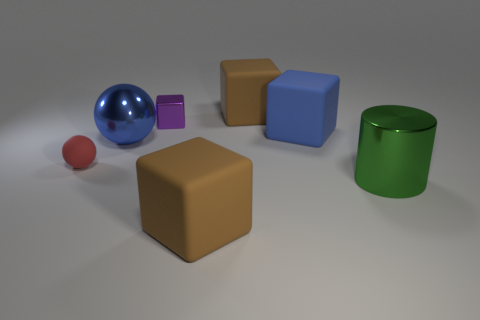The metallic block that is the same size as the red sphere is what color?
Your response must be concise. Purple. How many cylinders are yellow rubber objects or blue rubber things?
Your answer should be very brief. 0. Is the shape of the tiny purple metallic thing the same as the small matte object that is in front of the metal ball?
Your answer should be compact. No. How many yellow rubber cylinders are the same size as the blue cube?
Provide a short and direct response. 0. Is the shape of the brown matte object that is behind the red ball the same as the small object behind the large blue cube?
Offer a terse response. Yes. There is a rubber thing that is the same color as the large ball; what shape is it?
Make the answer very short. Cube. There is a big metallic object on the right side of the brown block in front of the blue matte block; what color is it?
Offer a terse response. Green. What is the color of the other big thing that is the same shape as the red rubber object?
Make the answer very short. Blue. Is there any other thing that has the same material as the large sphere?
Provide a short and direct response. Yes. There is another blue object that is the same shape as the tiny metal thing; what size is it?
Offer a very short reply. Large. 